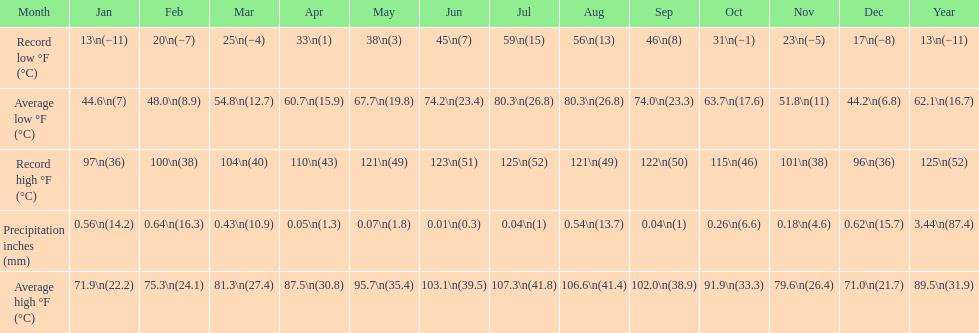How many months saw record lows below freezing? 7. 